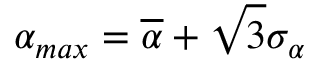Convert formula to latex. <formula><loc_0><loc_0><loc_500><loc_500>\alpha _ { \max } = \overline { \alpha } + \sqrt { 3 } \sigma _ { \alpha }</formula> 